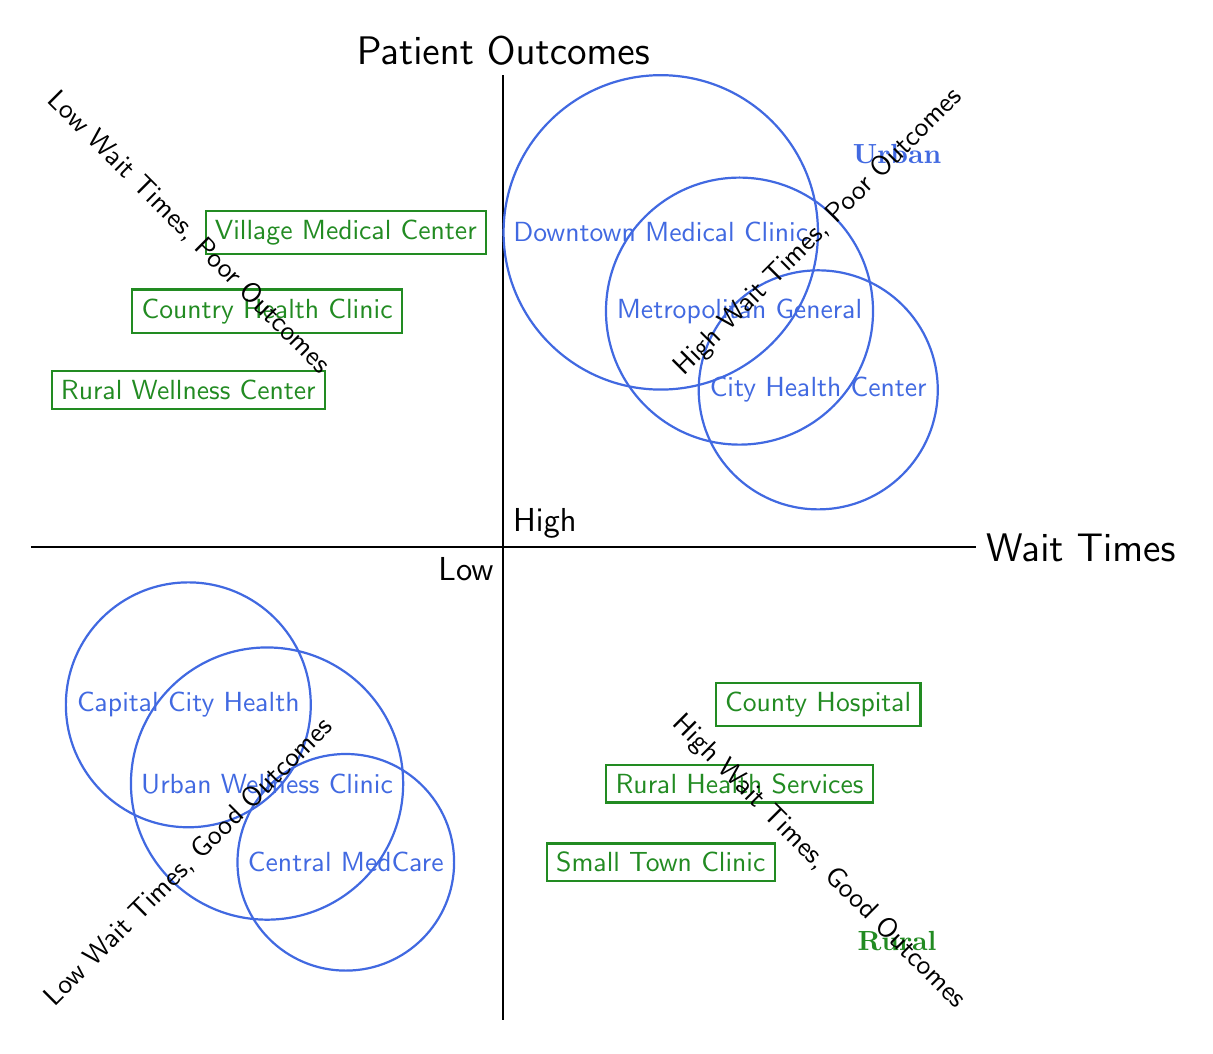What urban clinic has the highest mortality rate? The diagram indicates that "Metropolitan General" is located in the quadrant representing high wait times and poor outcomes, signifying it has the highest mortality rate among urban clinics.
Answer: Metropolitan General Which rural clinic has the highest satisfaction rate? The "Rural Wellness Center," found in the quadrant for low wait times and good outcomes, is indicated as having the highest satisfaction rate for rural clinics.
Answer: Rural Wellness Center How many urban clinics are categorized under high wait times? By counting the urban clinics in the high wait times quadrant, there are three clinics: "Metropolitan General," "City Health Center," and "Downtown Medical Clinic."
Answer: 3 What is the patient outcome for "Country Health Clinic"? The "Country Health Clinic" is in the low wait times and good outcomes quadrant, indicating it has a low mortality rate.
Answer: Low mortality rate Which setting has better patient outcomes associated with low wait times? Comparing both urban and rural settings, the rural setting's "Country Health Clinic," "Rural Wellness Center," and "Village Medical Center" show better outcomes compared to urban clinics, which also have good outcomes but fewer clinics in that quadrant.
Answer: Rural Which clinic has the lowest complication rate in urban settings? "Central MedCare," located in the low wait times and good outcomes quadrant, has the lowest complication rate among urban clinics.
Answer: Central MedCare What relationship exists between wait times and patient outcomes in rural areas? In rural areas, there is a clear relationship where low wait times are associated with good patient outcomes, as shown by the clinics in that quadrant.
Answer: Positive relationship Which urban clinic presents poor outcomes associated with high wait times? In the high wait times and poor outcomes quadrant, the "City Health Center" is identified as having a low satisfaction rate and represents poor outcomes.
Answer: City Health Center 